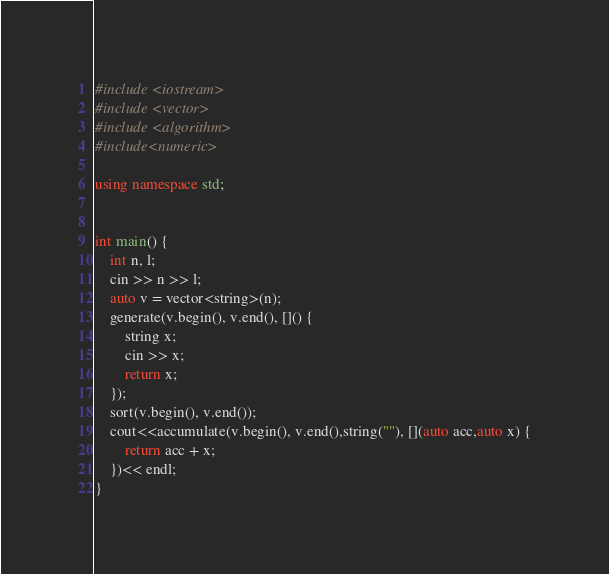Convert code to text. <code><loc_0><loc_0><loc_500><loc_500><_C++_>#include <iostream>
#include <vector>
#include <algorithm>
#include<numeric>

using namespace std;


int main() {
	int n, l;
	cin >> n >> l;
	auto v = vector<string>(n);
	generate(v.begin(), v.end(), []() {
		string x;
		cin >> x;
		return x;
	});
	sort(v.begin(), v.end());
	cout<<accumulate(v.begin(), v.end(),string(""), [](auto acc,auto x) {
		return acc + x;
	})<< endl;
}</code> 